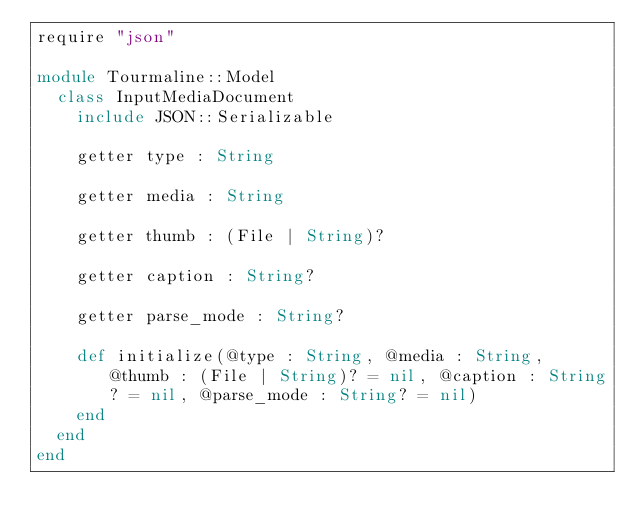<code> <loc_0><loc_0><loc_500><loc_500><_Crystal_>require "json"

module Tourmaline::Model
  class InputMediaDocument
    include JSON::Serializable

    getter type : String

    getter media : String

    getter thumb : (File | String)?

    getter caption : String?

    getter parse_mode : String?

    def initialize(@type : String, @media : String, @thumb : (File | String)? = nil, @caption : String? = nil, @parse_mode : String? = nil)
    end
  end
end
</code> 